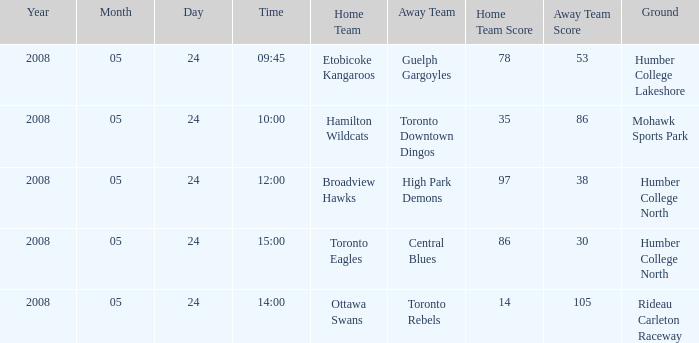On what grounds did the away team of the Toronto Rebels play? Rideau Carleton Raceway. 